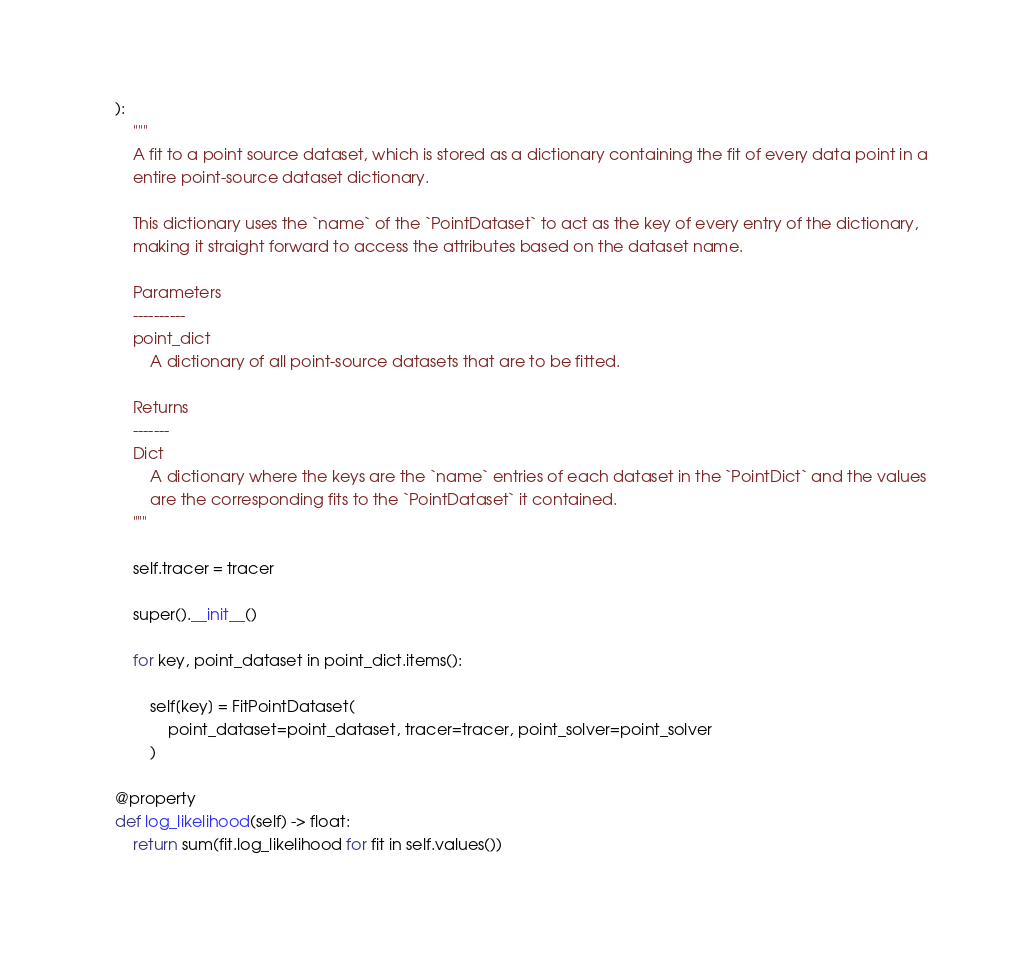Convert code to text. <code><loc_0><loc_0><loc_500><loc_500><_Python_>    ):
        """
        A fit to a point source dataset, which is stored as a dictionary containing the fit of every data point in a
        entire point-source dataset dictionary.

        This dictionary uses the `name` of the `PointDataset` to act as the key of every entry of the dictionary,
        making it straight forward to access the attributes based on the dataset name.

        Parameters
        ----------
        point_dict
            A dictionary of all point-source datasets that are to be fitted.

        Returns
        -------
        Dict
            A dictionary where the keys are the `name` entries of each dataset in the `PointDict` and the values
            are the corresponding fits to the `PointDataset` it contained.
        """

        self.tracer = tracer

        super().__init__()

        for key, point_dataset in point_dict.items():

            self[key] = FitPointDataset(
                point_dataset=point_dataset, tracer=tracer, point_solver=point_solver
            )

    @property
    def log_likelihood(self) -> float:
        return sum(fit.log_likelihood for fit in self.values())
</code> 